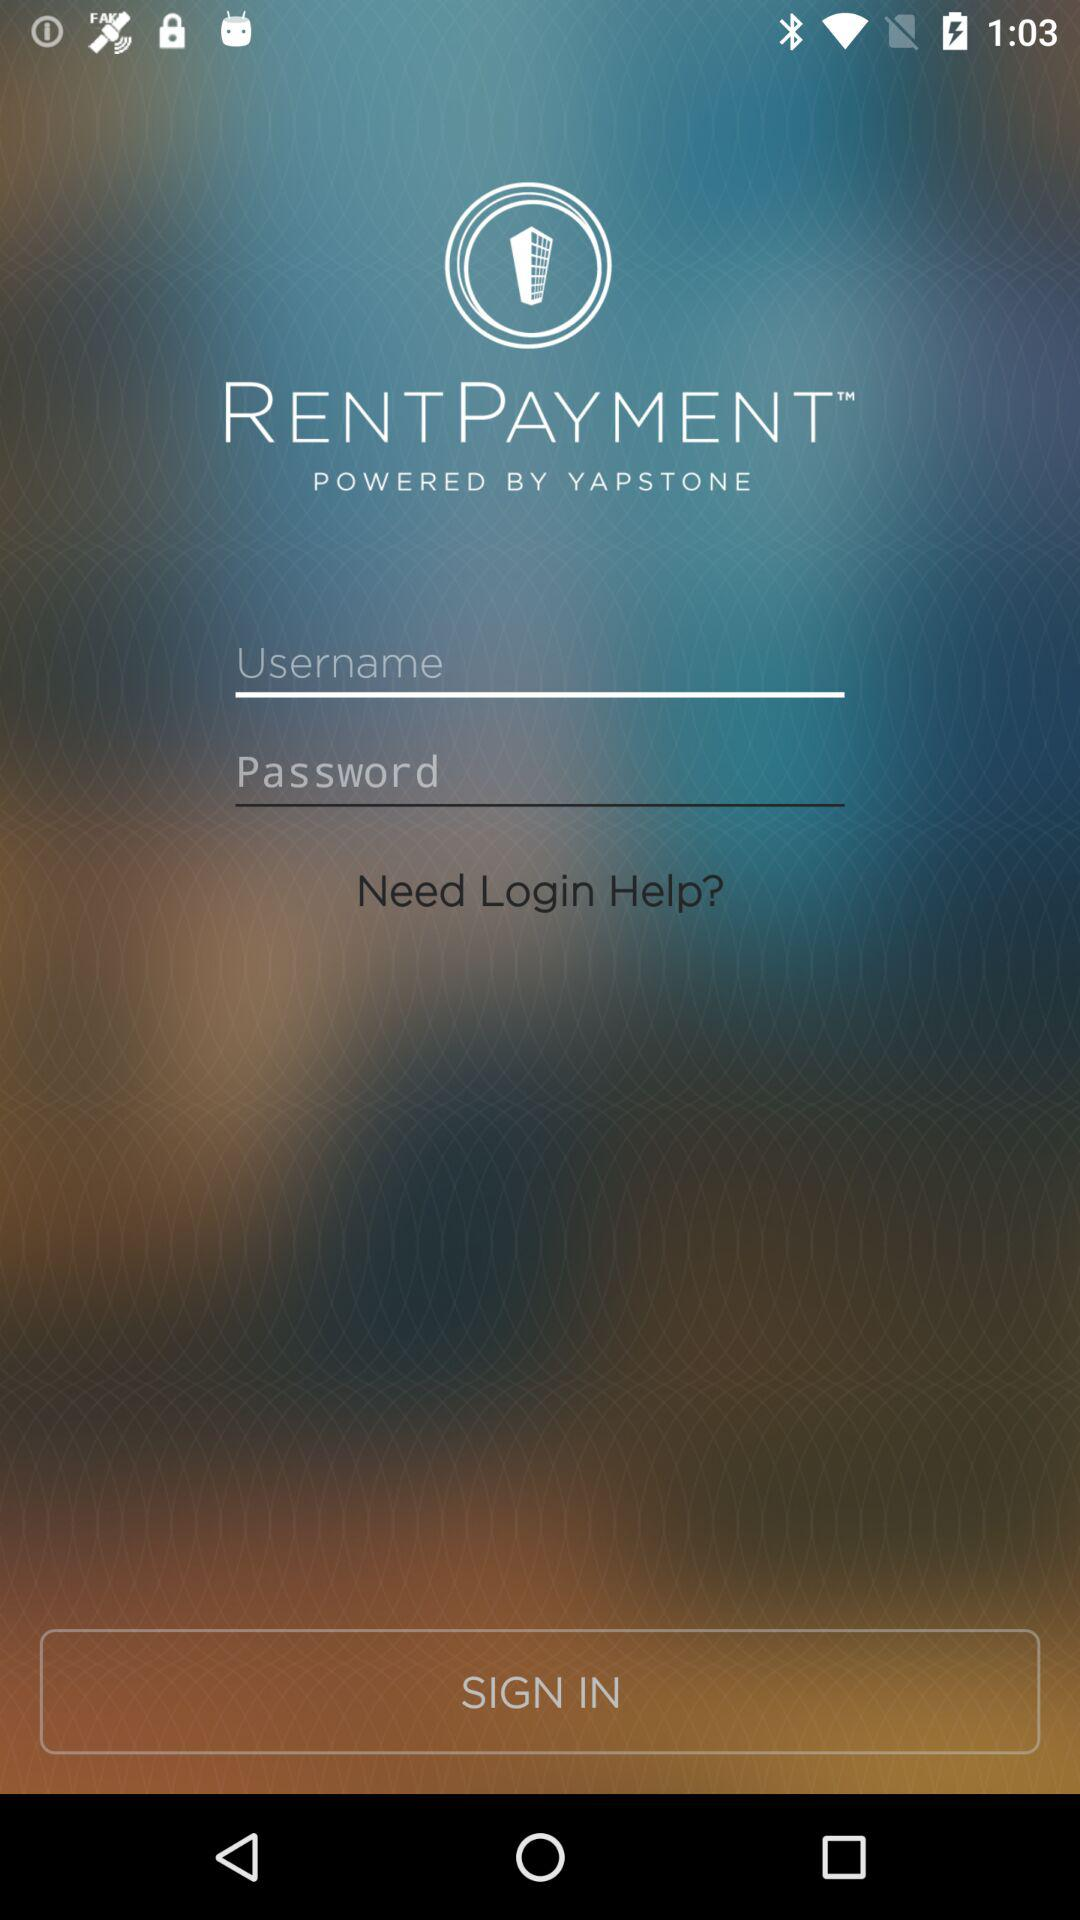What is the application name? The application name is "RENTPAYMENT". 